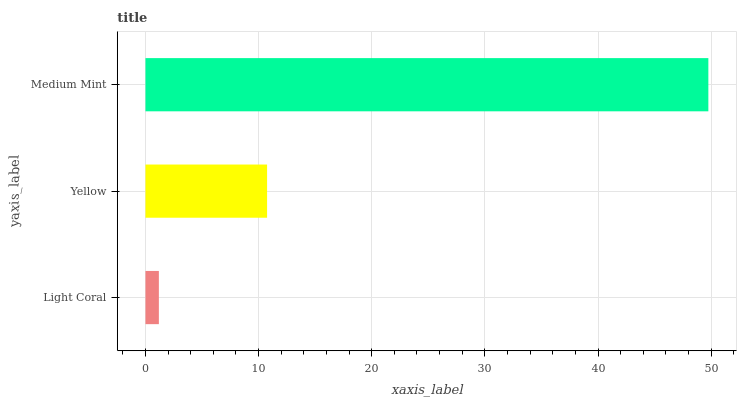Is Light Coral the minimum?
Answer yes or no. Yes. Is Medium Mint the maximum?
Answer yes or no. Yes. Is Yellow the minimum?
Answer yes or no. No. Is Yellow the maximum?
Answer yes or no. No. Is Yellow greater than Light Coral?
Answer yes or no. Yes. Is Light Coral less than Yellow?
Answer yes or no. Yes. Is Light Coral greater than Yellow?
Answer yes or no. No. Is Yellow less than Light Coral?
Answer yes or no. No. Is Yellow the high median?
Answer yes or no. Yes. Is Yellow the low median?
Answer yes or no. Yes. Is Medium Mint the high median?
Answer yes or no. No. Is Light Coral the low median?
Answer yes or no. No. 